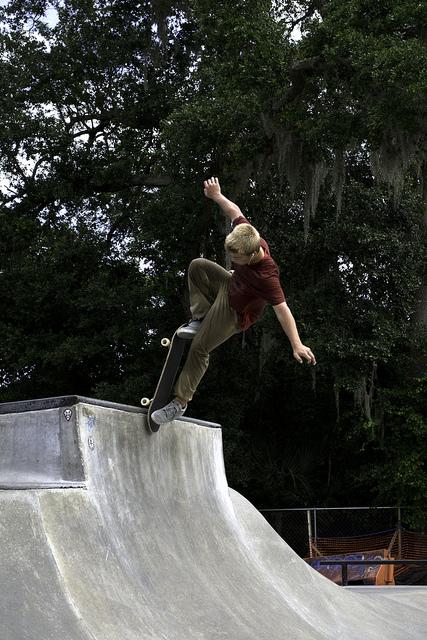Is it dangerous what the boy is doing?
Keep it brief. Yes. Is this  guy very worried about his head?
Be succinct. No. Will the boy make the jump?
Keep it brief. Yes. 